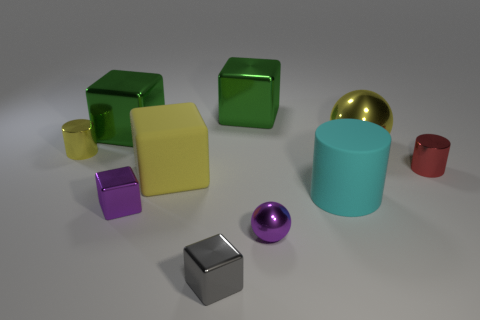Subtract all tiny metal cubes. How many cubes are left? 3 Subtract all blue balls. How many green blocks are left? 2 Subtract all gray cubes. How many cubes are left? 4 Subtract 2 blocks. How many blocks are left? 3 Subtract all cylinders. How many objects are left? 7 Add 3 matte things. How many matte things are left? 5 Add 7 large cyan objects. How many large cyan objects exist? 8 Subtract 1 cyan cylinders. How many objects are left? 9 Subtract all green blocks. Subtract all gray cylinders. How many blocks are left? 3 Subtract all purple shiny balls. Subtract all large cyan blocks. How many objects are left? 9 